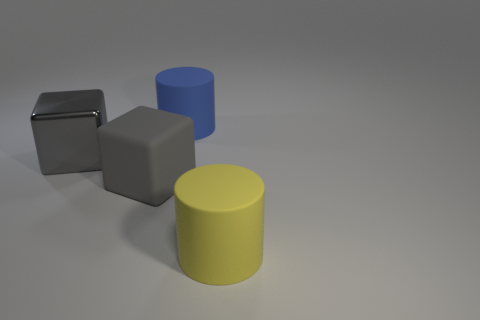Is the color of the large shiny object the same as the big rubber block?
Your answer should be compact. Yes. What number of cylinders are both in front of the large rubber block and on the left side of the yellow cylinder?
Offer a terse response. 0. What number of shiny objects are either large yellow objects or blue objects?
Keep it short and to the point. 0. What material is the cylinder that is right of the thing behind the gray shiny cube?
Ensure brevity in your answer.  Rubber. What is the shape of the yellow object that is the same size as the gray shiny thing?
Keep it short and to the point. Cylinder. Are there fewer big brown shiny blocks than big yellow cylinders?
Your answer should be very brief. Yes. There is a gray thing to the right of the large gray shiny cube; are there any yellow cylinders behind it?
Your answer should be very brief. No. There is a big gray thing that is made of the same material as the blue cylinder; what is its shape?
Your answer should be compact. Cube. Is there any other thing of the same color as the big metal object?
Offer a terse response. Yes. What material is the other large thing that is the same shape as the big blue matte thing?
Your response must be concise. Rubber. 